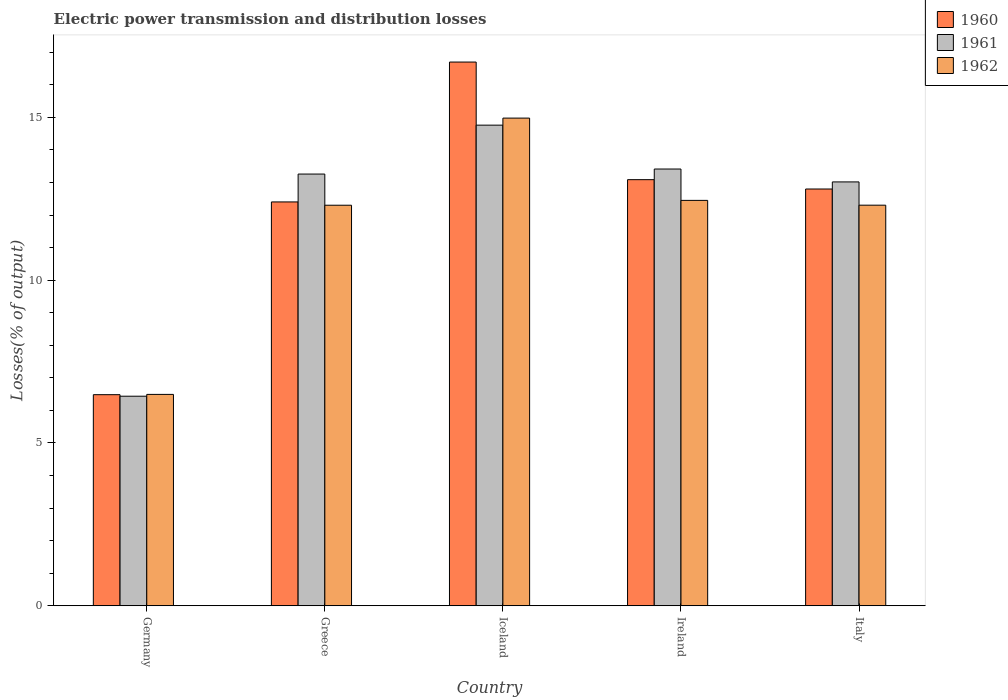How many bars are there on the 4th tick from the left?
Give a very brief answer. 3. How many bars are there on the 4th tick from the right?
Offer a terse response. 3. What is the label of the 4th group of bars from the left?
Give a very brief answer. Ireland. In how many cases, is the number of bars for a given country not equal to the number of legend labels?
Make the answer very short. 0. What is the electric power transmission and distribution losses in 1960 in Iceland?
Offer a very short reply. 16.7. Across all countries, what is the maximum electric power transmission and distribution losses in 1961?
Offer a terse response. 14.76. Across all countries, what is the minimum electric power transmission and distribution losses in 1960?
Offer a terse response. 6.48. In which country was the electric power transmission and distribution losses in 1962 minimum?
Offer a terse response. Germany. What is the total electric power transmission and distribution losses in 1960 in the graph?
Ensure brevity in your answer.  61.47. What is the difference between the electric power transmission and distribution losses in 1961 in Iceland and that in Italy?
Offer a terse response. 1.74. What is the difference between the electric power transmission and distribution losses in 1961 in Ireland and the electric power transmission and distribution losses in 1962 in Germany?
Ensure brevity in your answer.  6.92. What is the average electric power transmission and distribution losses in 1962 per country?
Keep it short and to the point. 11.7. What is the difference between the electric power transmission and distribution losses of/in 1961 and electric power transmission and distribution losses of/in 1960 in Greece?
Make the answer very short. 0.86. What is the ratio of the electric power transmission and distribution losses in 1960 in Germany to that in Ireland?
Your response must be concise. 0.5. Is the difference between the electric power transmission and distribution losses in 1961 in Germany and Italy greater than the difference between the electric power transmission and distribution losses in 1960 in Germany and Italy?
Provide a succinct answer. No. What is the difference between the highest and the second highest electric power transmission and distribution losses in 1962?
Your answer should be compact. 0.15. What is the difference between the highest and the lowest electric power transmission and distribution losses in 1962?
Provide a short and direct response. 8.48. In how many countries, is the electric power transmission and distribution losses in 1962 greater than the average electric power transmission and distribution losses in 1962 taken over all countries?
Provide a short and direct response. 4. What does the 1st bar from the left in Germany represents?
Offer a terse response. 1960. Is it the case that in every country, the sum of the electric power transmission and distribution losses in 1962 and electric power transmission and distribution losses in 1960 is greater than the electric power transmission and distribution losses in 1961?
Your response must be concise. Yes. Are all the bars in the graph horizontal?
Provide a short and direct response. No. How many countries are there in the graph?
Ensure brevity in your answer.  5. Are the values on the major ticks of Y-axis written in scientific E-notation?
Give a very brief answer. No. Does the graph contain any zero values?
Make the answer very short. No. How many legend labels are there?
Your answer should be very brief. 3. How are the legend labels stacked?
Your response must be concise. Vertical. What is the title of the graph?
Offer a terse response. Electric power transmission and distribution losses. What is the label or title of the X-axis?
Your answer should be very brief. Country. What is the label or title of the Y-axis?
Make the answer very short. Losses(% of output). What is the Losses(% of output) in 1960 in Germany?
Ensure brevity in your answer.  6.48. What is the Losses(% of output) in 1961 in Germany?
Your answer should be very brief. 6.44. What is the Losses(% of output) in 1962 in Germany?
Give a very brief answer. 6.49. What is the Losses(% of output) in 1960 in Greece?
Offer a very short reply. 12.4. What is the Losses(% of output) of 1961 in Greece?
Make the answer very short. 13.26. What is the Losses(% of output) in 1962 in Greece?
Your response must be concise. 12.3. What is the Losses(% of output) of 1960 in Iceland?
Offer a very short reply. 16.7. What is the Losses(% of output) of 1961 in Iceland?
Make the answer very short. 14.76. What is the Losses(% of output) of 1962 in Iceland?
Ensure brevity in your answer.  14.98. What is the Losses(% of output) in 1960 in Ireland?
Offer a very short reply. 13.09. What is the Losses(% of output) of 1961 in Ireland?
Provide a short and direct response. 13.41. What is the Losses(% of output) in 1962 in Ireland?
Give a very brief answer. 12.45. What is the Losses(% of output) in 1960 in Italy?
Offer a terse response. 12.8. What is the Losses(% of output) of 1961 in Italy?
Keep it short and to the point. 13.02. What is the Losses(% of output) of 1962 in Italy?
Provide a short and direct response. 12.3. Across all countries, what is the maximum Losses(% of output) in 1960?
Offer a very short reply. 16.7. Across all countries, what is the maximum Losses(% of output) of 1961?
Provide a succinct answer. 14.76. Across all countries, what is the maximum Losses(% of output) of 1962?
Ensure brevity in your answer.  14.98. Across all countries, what is the minimum Losses(% of output) of 1960?
Your answer should be compact. 6.48. Across all countries, what is the minimum Losses(% of output) in 1961?
Your answer should be compact. 6.44. Across all countries, what is the minimum Losses(% of output) in 1962?
Your answer should be very brief. 6.49. What is the total Losses(% of output) in 1960 in the graph?
Provide a short and direct response. 61.47. What is the total Losses(% of output) in 1961 in the graph?
Give a very brief answer. 60.88. What is the total Losses(% of output) of 1962 in the graph?
Offer a terse response. 58.52. What is the difference between the Losses(% of output) in 1960 in Germany and that in Greece?
Your response must be concise. -5.92. What is the difference between the Losses(% of output) of 1961 in Germany and that in Greece?
Your answer should be very brief. -6.82. What is the difference between the Losses(% of output) in 1962 in Germany and that in Greece?
Your answer should be compact. -5.81. What is the difference between the Losses(% of output) in 1960 in Germany and that in Iceland?
Ensure brevity in your answer.  -10.21. What is the difference between the Losses(% of output) in 1961 in Germany and that in Iceland?
Your response must be concise. -8.32. What is the difference between the Losses(% of output) in 1962 in Germany and that in Iceland?
Ensure brevity in your answer.  -8.48. What is the difference between the Losses(% of output) of 1960 in Germany and that in Ireland?
Provide a short and direct response. -6.6. What is the difference between the Losses(% of output) of 1961 in Germany and that in Ireland?
Ensure brevity in your answer.  -6.98. What is the difference between the Losses(% of output) of 1962 in Germany and that in Ireland?
Make the answer very short. -5.96. What is the difference between the Losses(% of output) in 1960 in Germany and that in Italy?
Ensure brevity in your answer.  -6.32. What is the difference between the Losses(% of output) in 1961 in Germany and that in Italy?
Your answer should be very brief. -6.58. What is the difference between the Losses(% of output) in 1962 in Germany and that in Italy?
Your response must be concise. -5.81. What is the difference between the Losses(% of output) in 1960 in Greece and that in Iceland?
Your response must be concise. -4.3. What is the difference between the Losses(% of output) of 1961 in Greece and that in Iceland?
Offer a terse response. -1.5. What is the difference between the Losses(% of output) of 1962 in Greece and that in Iceland?
Your answer should be compact. -2.68. What is the difference between the Losses(% of output) in 1960 in Greece and that in Ireland?
Ensure brevity in your answer.  -0.68. What is the difference between the Losses(% of output) in 1961 in Greece and that in Ireland?
Offer a very short reply. -0.15. What is the difference between the Losses(% of output) in 1962 in Greece and that in Ireland?
Make the answer very short. -0.15. What is the difference between the Losses(% of output) of 1960 in Greece and that in Italy?
Provide a succinct answer. -0.4. What is the difference between the Losses(% of output) in 1961 in Greece and that in Italy?
Provide a short and direct response. 0.24. What is the difference between the Losses(% of output) in 1962 in Greece and that in Italy?
Your response must be concise. -0. What is the difference between the Losses(% of output) in 1960 in Iceland and that in Ireland?
Provide a short and direct response. 3.61. What is the difference between the Losses(% of output) of 1961 in Iceland and that in Ireland?
Your answer should be compact. 1.35. What is the difference between the Losses(% of output) of 1962 in Iceland and that in Ireland?
Ensure brevity in your answer.  2.53. What is the difference between the Losses(% of output) of 1960 in Iceland and that in Italy?
Offer a very short reply. 3.9. What is the difference between the Losses(% of output) in 1961 in Iceland and that in Italy?
Provide a short and direct response. 1.74. What is the difference between the Losses(% of output) of 1962 in Iceland and that in Italy?
Your answer should be very brief. 2.67. What is the difference between the Losses(% of output) of 1960 in Ireland and that in Italy?
Your answer should be very brief. 0.29. What is the difference between the Losses(% of output) of 1961 in Ireland and that in Italy?
Keep it short and to the point. 0.4. What is the difference between the Losses(% of output) of 1962 in Ireland and that in Italy?
Keep it short and to the point. 0.15. What is the difference between the Losses(% of output) in 1960 in Germany and the Losses(% of output) in 1961 in Greece?
Your answer should be compact. -6.78. What is the difference between the Losses(% of output) of 1960 in Germany and the Losses(% of output) of 1962 in Greece?
Offer a terse response. -5.82. What is the difference between the Losses(% of output) of 1961 in Germany and the Losses(% of output) of 1962 in Greece?
Offer a very short reply. -5.86. What is the difference between the Losses(% of output) in 1960 in Germany and the Losses(% of output) in 1961 in Iceland?
Your answer should be compact. -8.28. What is the difference between the Losses(% of output) of 1960 in Germany and the Losses(% of output) of 1962 in Iceland?
Keep it short and to the point. -8.49. What is the difference between the Losses(% of output) of 1961 in Germany and the Losses(% of output) of 1962 in Iceland?
Your answer should be compact. -8.54. What is the difference between the Losses(% of output) of 1960 in Germany and the Losses(% of output) of 1961 in Ireland?
Provide a short and direct response. -6.93. What is the difference between the Losses(% of output) in 1960 in Germany and the Losses(% of output) in 1962 in Ireland?
Your answer should be compact. -5.97. What is the difference between the Losses(% of output) of 1961 in Germany and the Losses(% of output) of 1962 in Ireland?
Your answer should be compact. -6.01. What is the difference between the Losses(% of output) in 1960 in Germany and the Losses(% of output) in 1961 in Italy?
Your response must be concise. -6.53. What is the difference between the Losses(% of output) of 1960 in Germany and the Losses(% of output) of 1962 in Italy?
Provide a succinct answer. -5.82. What is the difference between the Losses(% of output) of 1961 in Germany and the Losses(% of output) of 1962 in Italy?
Your answer should be compact. -5.87. What is the difference between the Losses(% of output) of 1960 in Greece and the Losses(% of output) of 1961 in Iceland?
Your answer should be compact. -2.36. What is the difference between the Losses(% of output) of 1960 in Greece and the Losses(% of output) of 1962 in Iceland?
Your answer should be compact. -2.57. What is the difference between the Losses(% of output) in 1961 in Greece and the Losses(% of output) in 1962 in Iceland?
Provide a short and direct response. -1.72. What is the difference between the Losses(% of output) of 1960 in Greece and the Losses(% of output) of 1961 in Ireland?
Provide a short and direct response. -1.01. What is the difference between the Losses(% of output) of 1960 in Greece and the Losses(% of output) of 1962 in Ireland?
Provide a short and direct response. -0.05. What is the difference between the Losses(% of output) in 1961 in Greece and the Losses(% of output) in 1962 in Ireland?
Your answer should be compact. 0.81. What is the difference between the Losses(% of output) of 1960 in Greece and the Losses(% of output) of 1961 in Italy?
Your answer should be very brief. -0.61. What is the difference between the Losses(% of output) in 1960 in Greece and the Losses(% of output) in 1962 in Italy?
Your answer should be compact. 0.1. What is the difference between the Losses(% of output) in 1961 in Greece and the Losses(% of output) in 1962 in Italy?
Keep it short and to the point. 0.96. What is the difference between the Losses(% of output) of 1960 in Iceland and the Losses(% of output) of 1961 in Ireland?
Your response must be concise. 3.28. What is the difference between the Losses(% of output) of 1960 in Iceland and the Losses(% of output) of 1962 in Ireland?
Give a very brief answer. 4.25. What is the difference between the Losses(% of output) of 1961 in Iceland and the Losses(% of output) of 1962 in Ireland?
Offer a terse response. 2.31. What is the difference between the Losses(% of output) of 1960 in Iceland and the Losses(% of output) of 1961 in Italy?
Provide a succinct answer. 3.68. What is the difference between the Losses(% of output) of 1960 in Iceland and the Losses(% of output) of 1962 in Italy?
Provide a short and direct response. 4.39. What is the difference between the Losses(% of output) of 1961 in Iceland and the Losses(% of output) of 1962 in Italy?
Offer a terse response. 2.46. What is the difference between the Losses(% of output) of 1960 in Ireland and the Losses(% of output) of 1961 in Italy?
Offer a very short reply. 0.07. What is the difference between the Losses(% of output) in 1960 in Ireland and the Losses(% of output) in 1962 in Italy?
Make the answer very short. 0.78. What is the difference between the Losses(% of output) in 1961 in Ireland and the Losses(% of output) in 1962 in Italy?
Offer a terse response. 1.11. What is the average Losses(% of output) of 1960 per country?
Your answer should be very brief. 12.29. What is the average Losses(% of output) in 1961 per country?
Your response must be concise. 12.18. What is the average Losses(% of output) of 1962 per country?
Provide a succinct answer. 11.7. What is the difference between the Losses(% of output) in 1960 and Losses(% of output) in 1961 in Germany?
Your response must be concise. 0.05. What is the difference between the Losses(% of output) in 1960 and Losses(% of output) in 1962 in Germany?
Offer a very short reply. -0.01. What is the difference between the Losses(% of output) in 1961 and Losses(% of output) in 1962 in Germany?
Keep it short and to the point. -0.06. What is the difference between the Losses(% of output) in 1960 and Losses(% of output) in 1961 in Greece?
Make the answer very short. -0.86. What is the difference between the Losses(% of output) of 1960 and Losses(% of output) of 1962 in Greece?
Provide a short and direct response. 0.1. What is the difference between the Losses(% of output) in 1961 and Losses(% of output) in 1962 in Greece?
Offer a very short reply. 0.96. What is the difference between the Losses(% of output) of 1960 and Losses(% of output) of 1961 in Iceland?
Ensure brevity in your answer.  1.94. What is the difference between the Losses(% of output) in 1960 and Losses(% of output) in 1962 in Iceland?
Your answer should be very brief. 1.72. What is the difference between the Losses(% of output) in 1961 and Losses(% of output) in 1962 in Iceland?
Make the answer very short. -0.22. What is the difference between the Losses(% of output) of 1960 and Losses(% of output) of 1961 in Ireland?
Make the answer very short. -0.33. What is the difference between the Losses(% of output) in 1960 and Losses(% of output) in 1962 in Ireland?
Your answer should be compact. 0.64. What is the difference between the Losses(% of output) in 1961 and Losses(% of output) in 1962 in Ireland?
Ensure brevity in your answer.  0.96. What is the difference between the Losses(% of output) of 1960 and Losses(% of output) of 1961 in Italy?
Make the answer very short. -0.22. What is the difference between the Losses(% of output) in 1960 and Losses(% of output) in 1962 in Italy?
Give a very brief answer. 0.5. What is the difference between the Losses(% of output) in 1961 and Losses(% of output) in 1962 in Italy?
Keep it short and to the point. 0.71. What is the ratio of the Losses(% of output) in 1960 in Germany to that in Greece?
Offer a very short reply. 0.52. What is the ratio of the Losses(% of output) of 1961 in Germany to that in Greece?
Offer a very short reply. 0.49. What is the ratio of the Losses(% of output) of 1962 in Germany to that in Greece?
Your answer should be compact. 0.53. What is the ratio of the Losses(% of output) of 1960 in Germany to that in Iceland?
Offer a very short reply. 0.39. What is the ratio of the Losses(% of output) in 1961 in Germany to that in Iceland?
Offer a very short reply. 0.44. What is the ratio of the Losses(% of output) in 1962 in Germany to that in Iceland?
Give a very brief answer. 0.43. What is the ratio of the Losses(% of output) of 1960 in Germany to that in Ireland?
Provide a short and direct response. 0.5. What is the ratio of the Losses(% of output) in 1961 in Germany to that in Ireland?
Offer a terse response. 0.48. What is the ratio of the Losses(% of output) in 1962 in Germany to that in Ireland?
Keep it short and to the point. 0.52. What is the ratio of the Losses(% of output) in 1960 in Germany to that in Italy?
Your answer should be very brief. 0.51. What is the ratio of the Losses(% of output) in 1961 in Germany to that in Italy?
Your answer should be compact. 0.49. What is the ratio of the Losses(% of output) in 1962 in Germany to that in Italy?
Your answer should be very brief. 0.53. What is the ratio of the Losses(% of output) of 1960 in Greece to that in Iceland?
Offer a very short reply. 0.74. What is the ratio of the Losses(% of output) of 1961 in Greece to that in Iceland?
Provide a succinct answer. 0.9. What is the ratio of the Losses(% of output) in 1962 in Greece to that in Iceland?
Your answer should be compact. 0.82. What is the ratio of the Losses(% of output) in 1960 in Greece to that in Ireland?
Provide a short and direct response. 0.95. What is the ratio of the Losses(% of output) in 1961 in Greece to that in Italy?
Keep it short and to the point. 1.02. What is the ratio of the Losses(% of output) of 1960 in Iceland to that in Ireland?
Give a very brief answer. 1.28. What is the ratio of the Losses(% of output) in 1961 in Iceland to that in Ireland?
Provide a succinct answer. 1.1. What is the ratio of the Losses(% of output) of 1962 in Iceland to that in Ireland?
Your answer should be compact. 1.2. What is the ratio of the Losses(% of output) in 1960 in Iceland to that in Italy?
Your answer should be compact. 1.3. What is the ratio of the Losses(% of output) in 1961 in Iceland to that in Italy?
Provide a succinct answer. 1.13. What is the ratio of the Losses(% of output) in 1962 in Iceland to that in Italy?
Your response must be concise. 1.22. What is the ratio of the Losses(% of output) in 1960 in Ireland to that in Italy?
Your answer should be very brief. 1.02. What is the ratio of the Losses(% of output) of 1961 in Ireland to that in Italy?
Your response must be concise. 1.03. What is the ratio of the Losses(% of output) in 1962 in Ireland to that in Italy?
Keep it short and to the point. 1.01. What is the difference between the highest and the second highest Losses(% of output) of 1960?
Ensure brevity in your answer.  3.61. What is the difference between the highest and the second highest Losses(% of output) of 1961?
Offer a very short reply. 1.35. What is the difference between the highest and the second highest Losses(% of output) of 1962?
Keep it short and to the point. 2.53. What is the difference between the highest and the lowest Losses(% of output) of 1960?
Your answer should be very brief. 10.21. What is the difference between the highest and the lowest Losses(% of output) of 1961?
Give a very brief answer. 8.32. What is the difference between the highest and the lowest Losses(% of output) of 1962?
Provide a succinct answer. 8.48. 